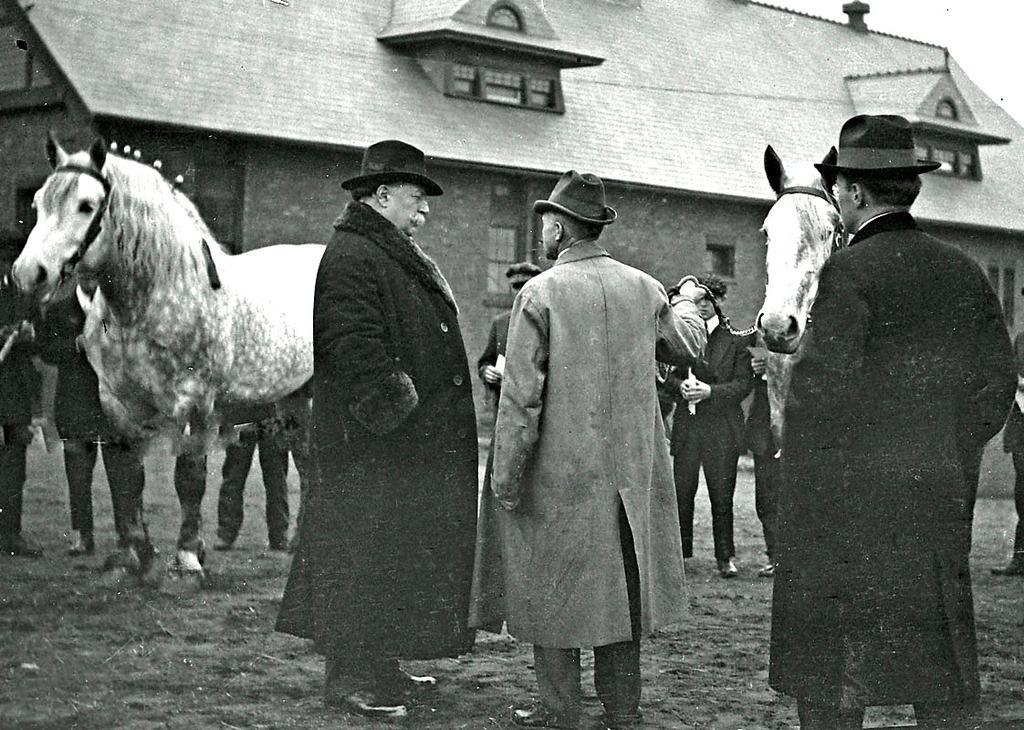In one or two sentences, can you explain what this image depicts? In this picture I can see in the middle few people are standing and talking, they are wearing coats, hats. There are horses on either side of this image, in the background it looks like a house. 